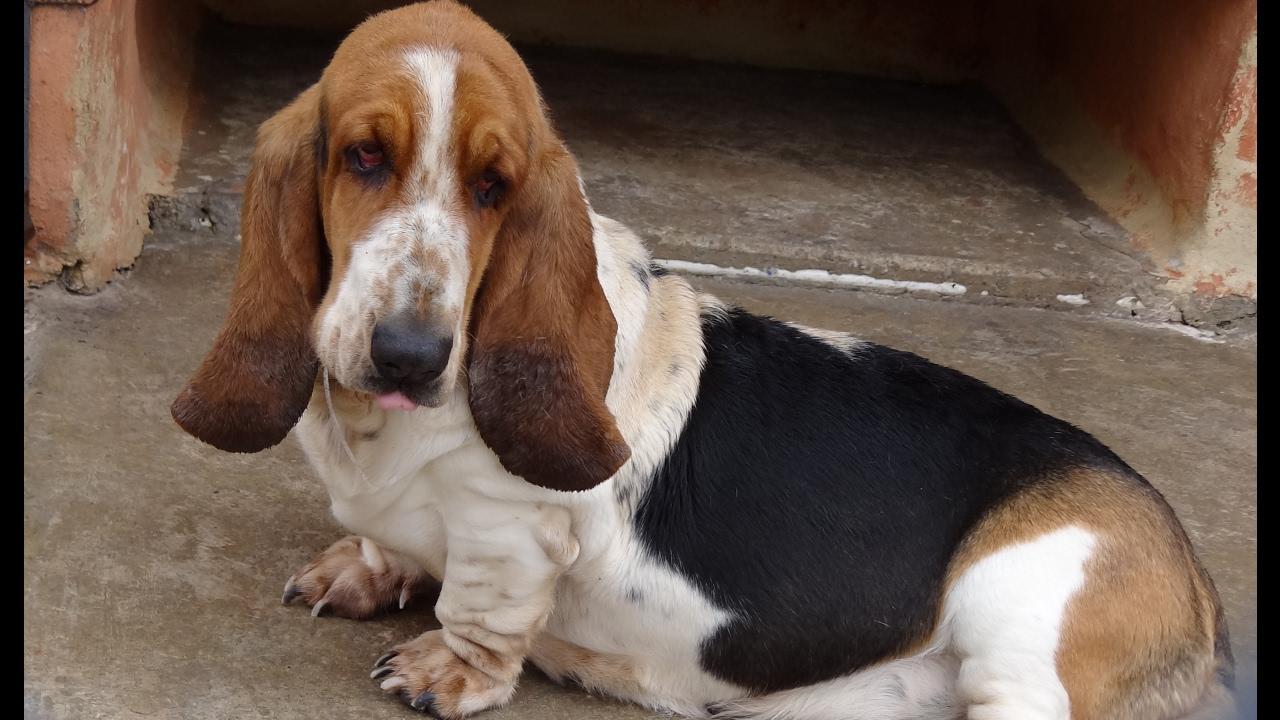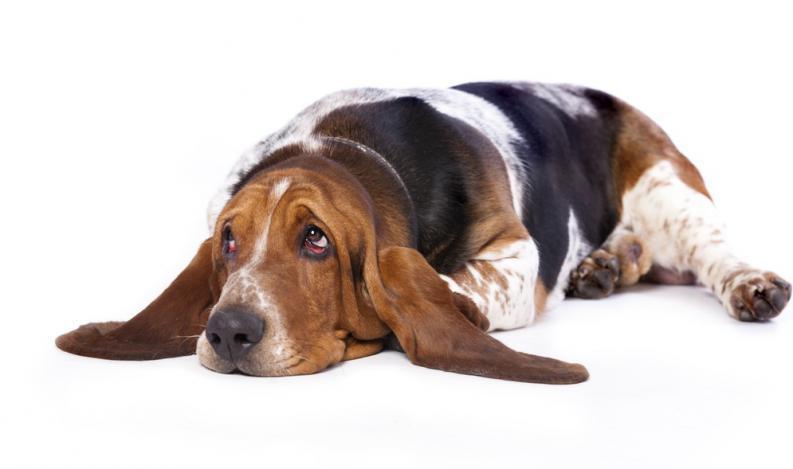The first image is the image on the left, the second image is the image on the right. Analyze the images presented: Is the assertion "Each image contains the same number of animals and contains more than one animal." valid? Answer yes or no. No. The first image is the image on the left, the second image is the image on the right. Given the left and right images, does the statement "There are no more than two dogs." hold true? Answer yes or no. Yes. 